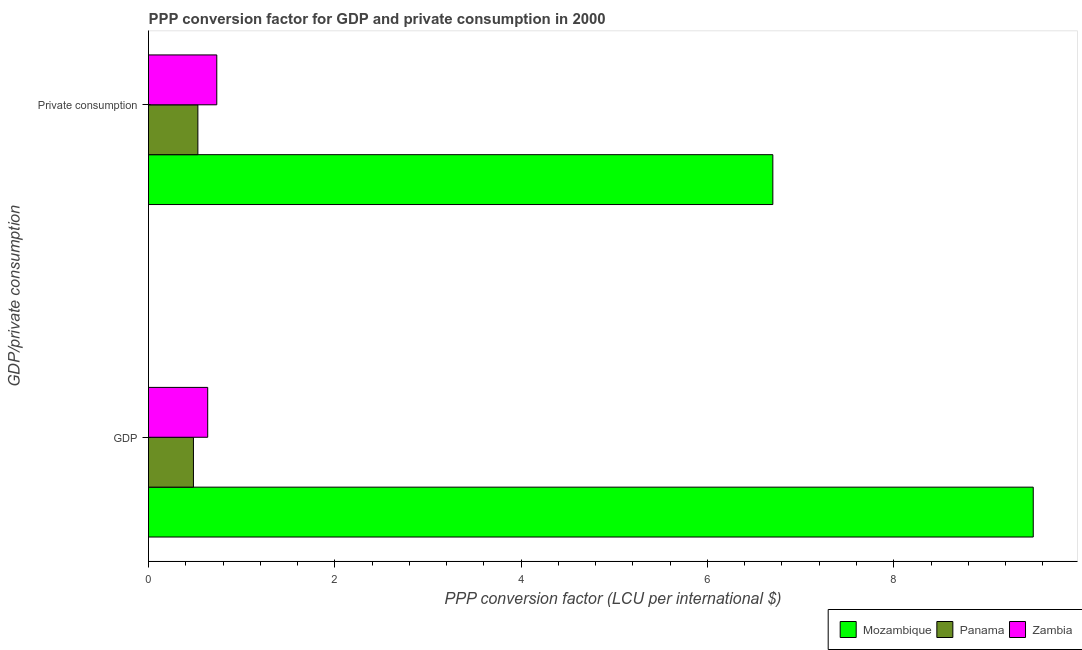How many different coloured bars are there?
Your answer should be compact. 3. How many groups of bars are there?
Your answer should be compact. 2. What is the label of the 2nd group of bars from the top?
Offer a very short reply. GDP. What is the ppp conversion factor for gdp in Zambia?
Your answer should be very brief. 0.64. Across all countries, what is the maximum ppp conversion factor for gdp?
Ensure brevity in your answer.  9.5. Across all countries, what is the minimum ppp conversion factor for private consumption?
Give a very brief answer. 0.53. In which country was the ppp conversion factor for private consumption maximum?
Your response must be concise. Mozambique. In which country was the ppp conversion factor for gdp minimum?
Give a very brief answer. Panama. What is the total ppp conversion factor for gdp in the graph?
Make the answer very short. 10.62. What is the difference between the ppp conversion factor for private consumption in Mozambique and that in Panama?
Your answer should be compact. 6.17. What is the difference between the ppp conversion factor for gdp in Zambia and the ppp conversion factor for private consumption in Panama?
Provide a short and direct response. 0.11. What is the average ppp conversion factor for private consumption per country?
Make the answer very short. 2.65. What is the difference between the ppp conversion factor for private consumption and ppp conversion factor for gdp in Mozambique?
Your response must be concise. -2.8. In how many countries, is the ppp conversion factor for gdp greater than 5.6 LCU?
Provide a succinct answer. 1. What is the ratio of the ppp conversion factor for gdp in Mozambique to that in Panama?
Provide a succinct answer. 19.7. What does the 1st bar from the top in  Private consumption represents?
Offer a terse response. Zambia. What does the 1st bar from the bottom in  Private consumption represents?
Offer a very short reply. Mozambique. How many bars are there?
Provide a short and direct response. 6. Are all the bars in the graph horizontal?
Keep it short and to the point. Yes. Are the values on the major ticks of X-axis written in scientific E-notation?
Your response must be concise. No. Does the graph contain grids?
Ensure brevity in your answer.  No. Where does the legend appear in the graph?
Your answer should be very brief. Bottom right. What is the title of the graph?
Give a very brief answer. PPP conversion factor for GDP and private consumption in 2000. Does "Sint Maarten (Dutch part)" appear as one of the legend labels in the graph?
Give a very brief answer. No. What is the label or title of the X-axis?
Provide a succinct answer. PPP conversion factor (LCU per international $). What is the label or title of the Y-axis?
Your response must be concise. GDP/private consumption. What is the PPP conversion factor (LCU per international $) in Mozambique in GDP?
Keep it short and to the point. 9.5. What is the PPP conversion factor (LCU per international $) in Panama in GDP?
Your answer should be compact. 0.48. What is the PPP conversion factor (LCU per international $) of Zambia in GDP?
Your response must be concise. 0.64. What is the PPP conversion factor (LCU per international $) in Mozambique in  Private consumption?
Give a very brief answer. 6.7. What is the PPP conversion factor (LCU per international $) in Panama in  Private consumption?
Ensure brevity in your answer.  0.53. What is the PPP conversion factor (LCU per international $) in Zambia in  Private consumption?
Offer a terse response. 0.73. Across all GDP/private consumption, what is the maximum PPP conversion factor (LCU per international $) in Mozambique?
Offer a very short reply. 9.5. Across all GDP/private consumption, what is the maximum PPP conversion factor (LCU per international $) in Panama?
Your answer should be very brief. 0.53. Across all GDP/private consumption, what is the maximum PPP conversion factor (LCU per international $) in Zambia?
Your answer should be compact. 0.73. Across all GDP/private consumption, what is the minimum PPP conversion factor (LCU per international $) in Mozambique?
Ensure brevity in your answer.  6.7. Across all GDP/private consumption, what is the minimum PPP conversion factor (LCU per international $) of Panama?
Keep it short and to the point. 0.48. Across all GDP/private consumption, what is the minimum PPP conversion factor (LCU per international $) in Zambia?
Provide a short and direct response. 0.64. What is the total PPP conversion factor (LCU per international $) in Mozambique in the graph?
Your answer should be very brief. 16.2. What is the total PPP conversion factor (LCU per international $) of Panama in the graph?
Make the answer very short. 1.01. What is the total PPP conversion factor (LCU per international $) in Zambia in the graph?
Ensure brevity in your answer.  1.37. What is the difference between the PPP conversion factor (LCU per international $) in Mozambique in GDP and that in  Private consumption?
Provide a short and direct response. 2.8. What is the difference between the PPP conversion factor (LCU per international $) in Panama in GDP and that in  Private consumption?
Ensure brevity in your answer.  -0.05. What is the difference between the PPP conversion factor (LCU per international $) of Zambia in GDP and that in  Private consumption?
Give a very brief answer. -0.1. What is the difference between the PPP conversion factor (LCU per international $) in Mozambique in GDP and the PPP conversion factor (LCU per international $) in Panama in  Private consumption?
Make the answer very short. 8.97. What is the difference between the PPP conversion factor (LCU per international $) in Mozambique in GDP and the PPP conversion factor (LCU per international $) in Zambia in  Private consumption?
Your response must be concise. 8.76. What is the difference between the PPP conversion factor (LCU per international $) in Panama in GDP and the PPP conversion factor (LCU per international $) in Zambia in  Private consumption?
Make the answer very short. -0.25. What is the average PPP conversion factor (LCU per international $) in Mozambique per GDP/private consumption?
Offer a very short reply. 8.1. What is the average PPP conversion factor (LCU per international $) of Panama per GDP/private consumption?
Offer a very short reply. 0.51. What is the average PPP conversion factor (LCU per international $) in Zambia per GDP/private consumption?
Your answer should be very brief. 0.68. What is the difference between the PPP conversion factor (LCU per international $) of Mozambique and PPP conversion factor (LCU per international $) of Panama in GDP?
Offer a terse response. 9.02. What is the difference between the PPP conversion factor (LCU per international $) of Mozambique and PPP conversion factor (LCU per international $) of Zambia in GDP?
Offer a terse response. 8.86. What is the difference between the PPP conversion factor (LCU per international $) in Panama and PPP conversion factor (LCU per international $) in Zambia in GDP?
Your answer should be very brief. -0.15. What is the difference between the PPP conversion factor (LCU per international $) in Mozambique and PPP conversion factor (LCU per international $) in Panama in  Private consumption?
Provide a succinct answer. 6.17. What is the difference between the PPP conversion factor (LCU per international $) of Mozambique and PPP conversion factor (LCU per international $) of Zambia in  Private consumption?
Your answer should be very brief. 5.97. What is the difference between the PPP conversion factor (LCU per international $) in Panama and PPP conversion factor (LCU per international $) in Zambia in  Private consumption?
Provide a short and direct response. -0.2. What is the ratio of the PPP conversion factor (LCU per international $) of Mozambique in GDP to that in  Private consumption?
Your answer should be very brief. 1.42. What is the ratio of the PPP conversion factor (LCU per international $) of Panama in GDP to that in  Private consumption?
Your answer should be compact. 0.91. What is the ratio of the PPP conversion factor (LCU per international $) in Zambia in GDP to that in  Private consumption?
Your answer should be compact. 0.87. What is the difference between the highest and the second highest PPP conversion factor (LCU per international $) in Mozambique?
Offer a terse response. 2.8. What is the difference between the highest and the second highest PPP conversion factor (LCU per international $) of Panama?
Your answer should be very brief. 0.05. What is the difference between the highest and the second highest PPP conversion factor (LCU per international $) of Zambia?
Offer a very short reply. 0.1. What is the difference between the highest and the lowest PPP conversion factor (LCU per international $) of Mozambique?
Your response must be concise. 2.8. What is the difference between the highest and the lowest PPP conversion factor (LCU per international $) in Panama?
Your response must be concise. 0.05. What is the difference between the highest and the lowest PPP conversion factor (LCU per international $) of Zambia?
Your answer should be very brief. 0.1. 